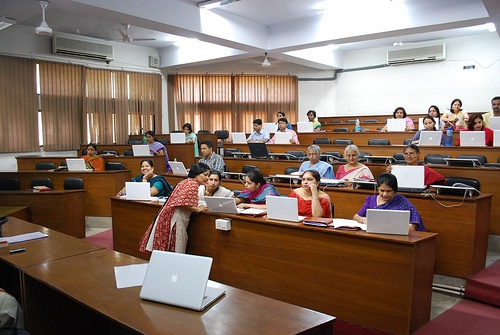Describe the objects in this image and their specific colors. I can see chair in gray, maroon, lightgray, and black tones, people in gray, lightgray, brown, maroon, and black tones, laptop in gray, lightgray, and darkgray tones, laptop in gray, lightgray, maroon, darkgray, and black tones, and people in gray, maroon, brown, black, and darkgray tones in this image. 